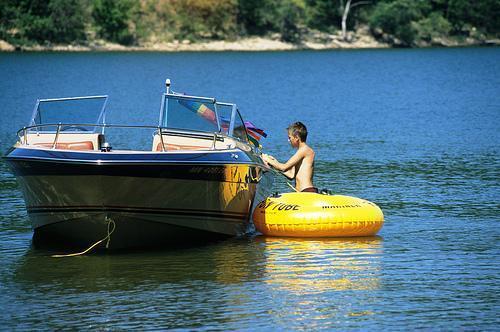How many people are in the photo?
Give a very brief answer. 1. 